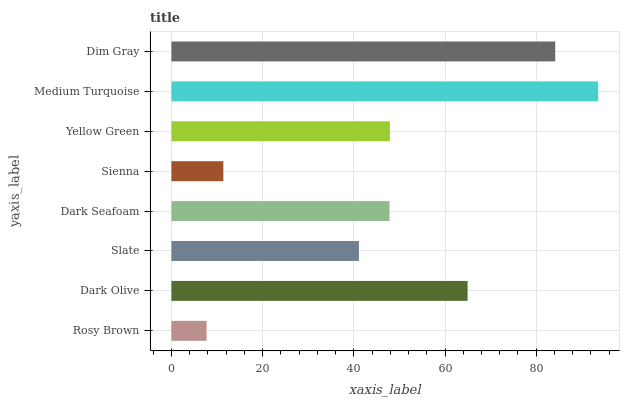Is Rosy Brown the minimum?
Answer yes or no. Yes. Is Medium Turquoise the maximum?
Answer yes or no. Yes. Is Dark Olive the minimum?
Answer yes or no. No. Is Dark Olive the maximum?
Answer yes or no. No. Is Dark Olive greater than Rosy Brown?
Answer yes or no. Yes. Is Rosy Brown less than Dark Olive?
Answer yes or no. Yes. Is Rosy Brown greater than Dark Olive?
Answer yes or no. No. Is Dark Olive less than Rosy Brown?
Answer yes or no. No. Is Yellow Green the high median?
Answer yes or no. Yes. Is Dark Seafoam the low median?
Answer yes or no. Yes. Is Dark Seafoam the high median?
Answer yes or no. No. Is Dark Olive the low median?
Answer yes or no. No. 